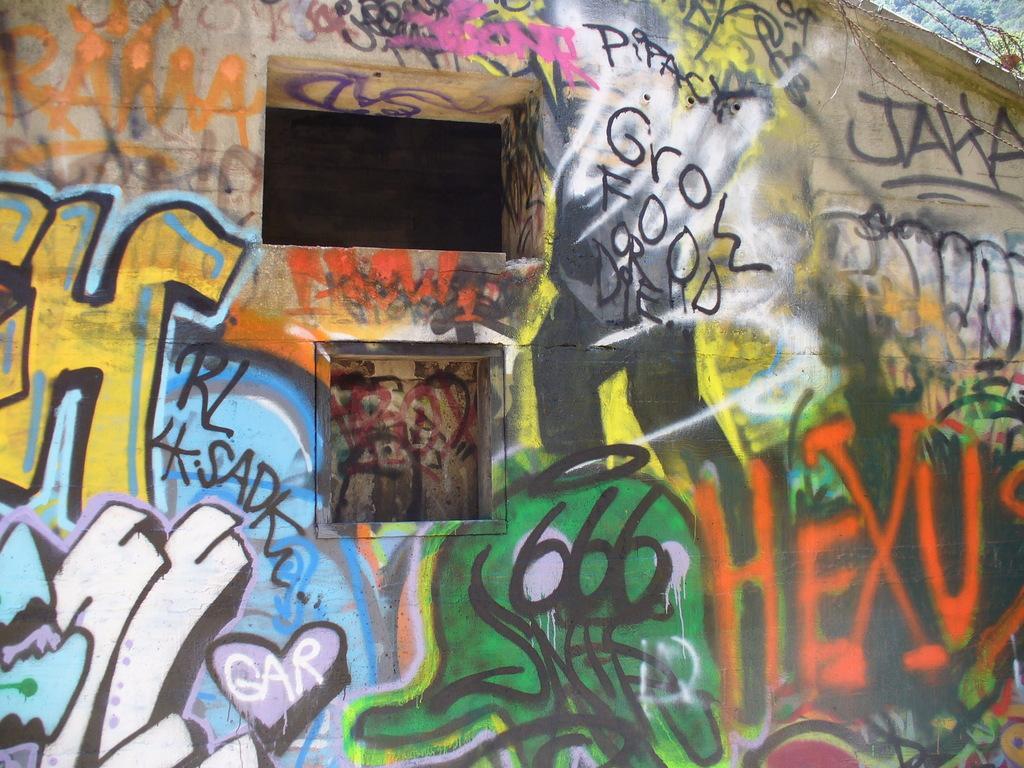Could you give a brief overview of what you see in this image? In this picture we can see graffiti on the wall and behind the wall there is a fence and trees. 